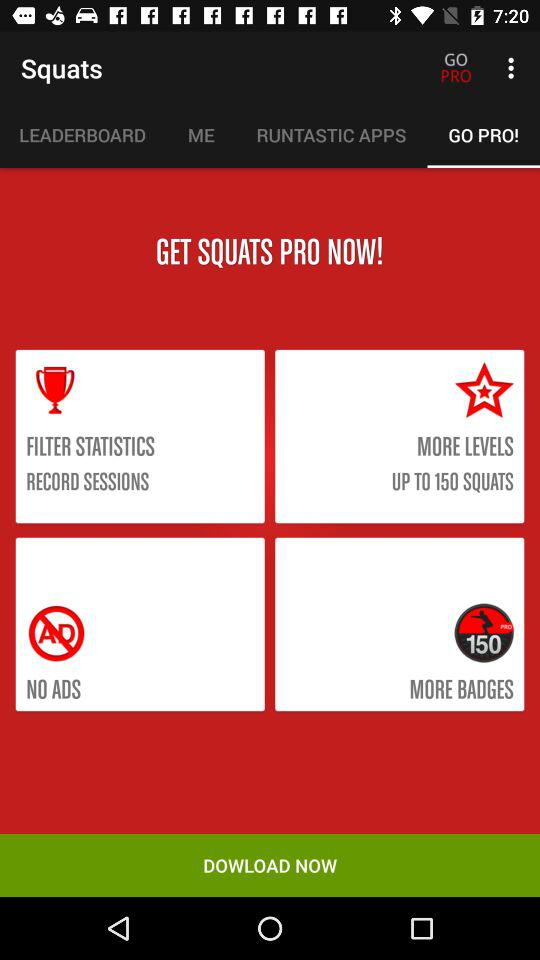What do more levels include? It includes up to 150 squats. 